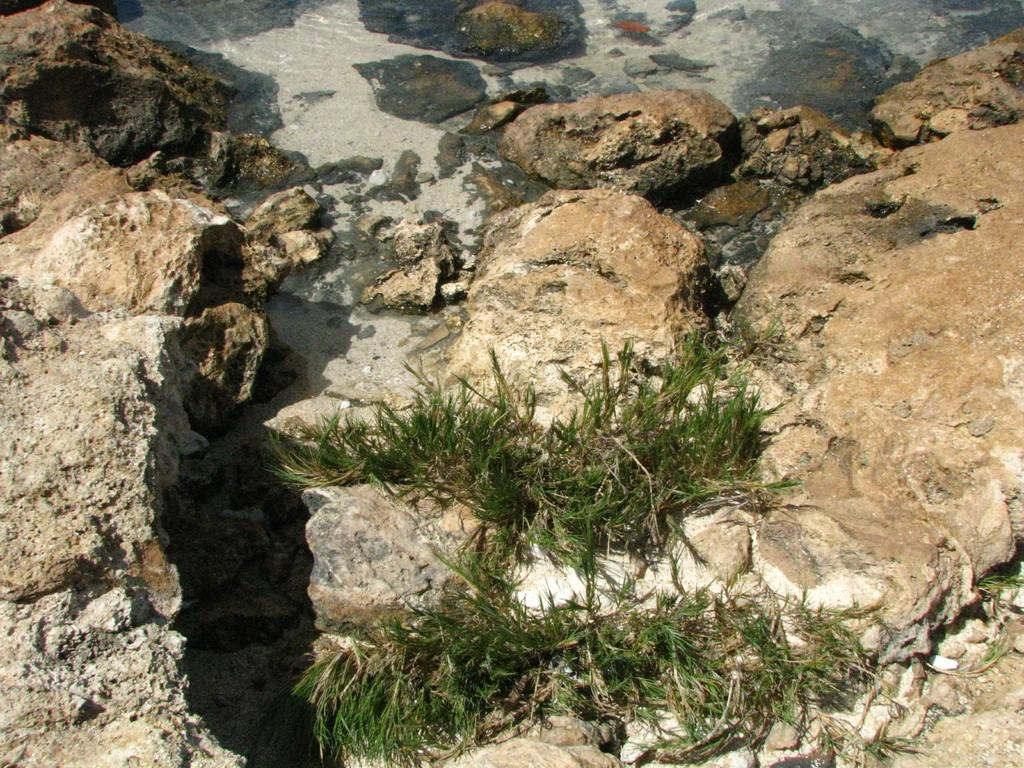What type of natural elements can be seen in the image? There are stones, grass, and water visible in the image. Can you describe the terrain in the image? The terrain in the image includes stones and grass. Is there any water present in the image? Yes, there is water visible in the image. What type of scissors can be seen cutting the grass in the image? There are no scissors present in the image; it only shows stones, grass, and water. How is the distribution of stones and grass managed in the image? The image does not provide information about the distribution of stones and grass being managed. 